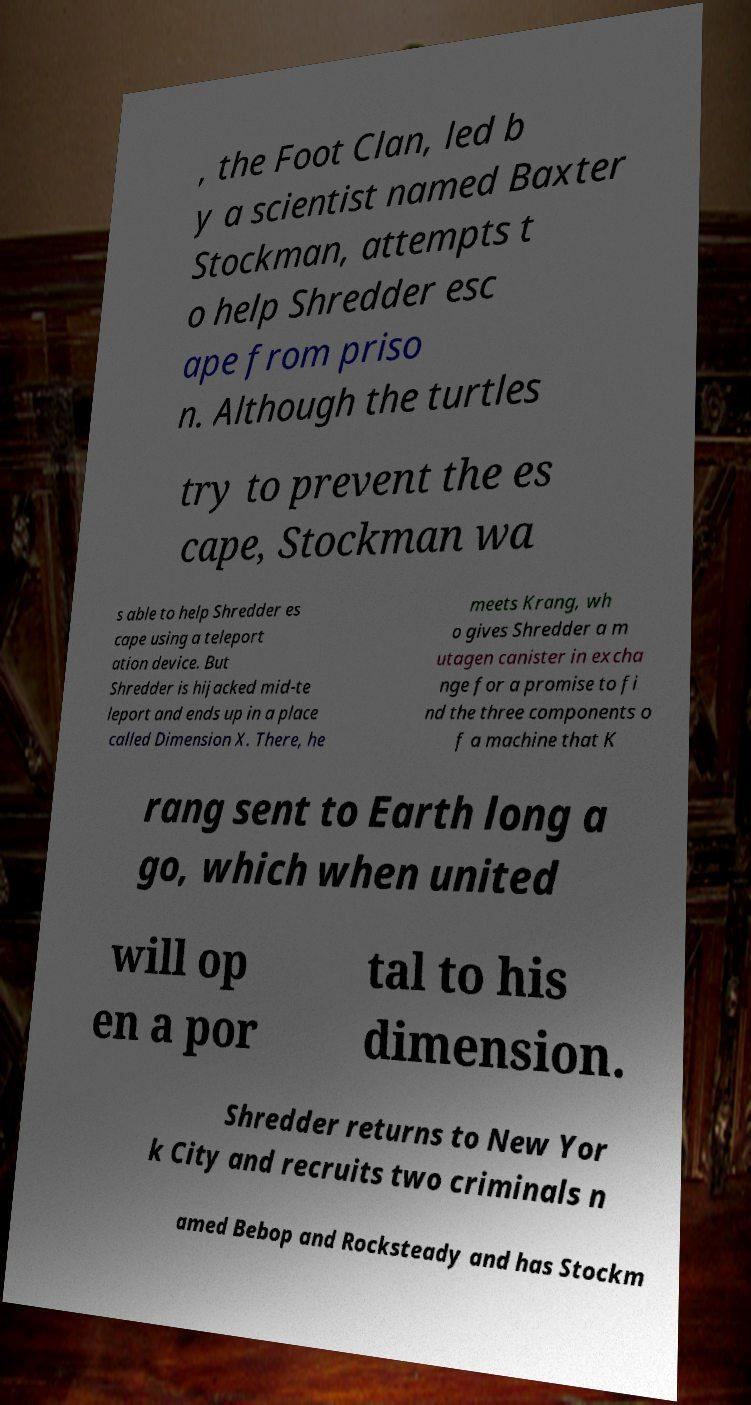For documentation purposes, I need the text within this image transcribed. Could you provide that? , the Foot Clan, led b y a scientist named Baxter Stockman, attempts t o help Shredder esc ape from priso n. Although the turtles try to prevent the es cape, Stockman wa s able to help Shredder es cape using a teleport ation device. But Shredder is hijacked mid-te leport and ends up in a place called Dimension X. There, he meets Krang, wh o gives Shredder a m utagen canister in excha nge for a promise to fi nd the three components o f a machine that K rang sent to Earth long a go, which when united will op en a por tal to his dimension. Shredder returns to New Yor k City and recruits two criminals n amed Bebop and Rocksteady and has Stockm 